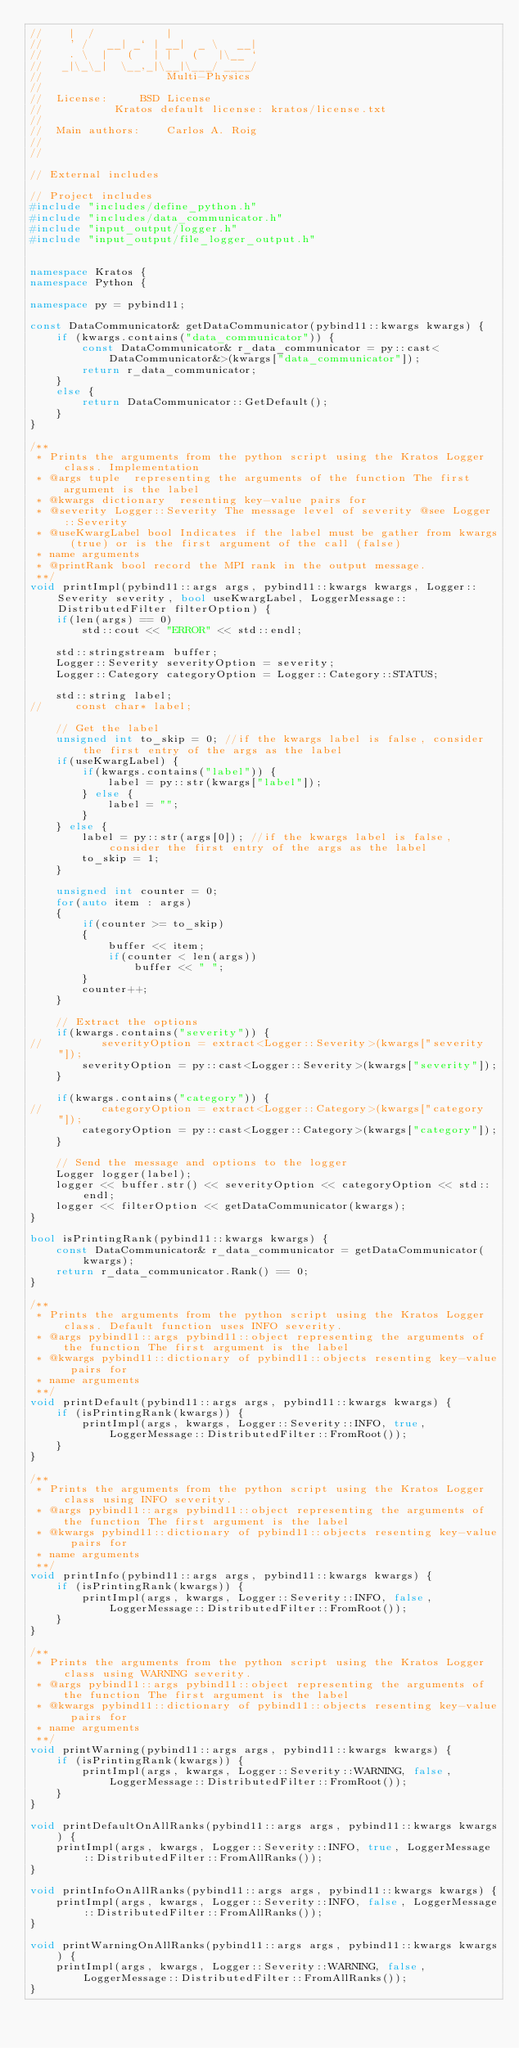<code> <loc_0><loc_0><loc_500><loc_500><_C++_>//    |  /           |
//    ' /   __| _` | __|  _ \   __|
//    . \  |   (   | |   (   |\__ `
//   _|\_\_|  \__,_|\__|\___/ ____/
//                   Multi-Physics
//
//  License:		 BSD License
//					 Kratos default license: kratos/license.txt
//
//  Main authors:    Carlos A. Roig
//
//

// External includes

// Project includes
#include "includes/define_python.h"
#include "includes/data_communicator.h"
#include "input_output/logger.h"
#include "input_output/file_logger_output.h"


namespace Kratos {
namespace Python {

namespace py = pybind11;

const DataCommunicator& getDataCommunicator(pybind11::kwargs kwargs) {
    if (kwargs.contains("data_communicator")) {
        const DataCommunicator& r_data_communicator = py::cast<DataCommunicator&>(kwargs["data_communicator"]);
        return r_data_communicator;
    }
    else {
        return DataCommunicator::GetDefault();
    }
}

/**
 * Prints the arguments from the python script using the Kratos Logger class. Implementation
 * @args tuple  representing the arguments of the function The first argument is the label
 * @kwargs dictionary  resenting key-value pairs for
 * @severity Logger::Severity The message level of severity @see Logger::Severity
 * @useKwargLabel bool Indicates if the label must be gather from kwargs (true) or is the first argument of the call (false)
 * name arguments
 * @printRank bool record the MPI rank in the output message.
 **/
void printImpl(pybind11::args args, pybind11::kwargs kwargs, Logger::Severity severity, bool useKwargLabel, LoggerMessage::DistributedFilter filterOption) {
    if(len(args) == 0)
        std::cout << "ERROR" << std::endl;

    std::stringstream buffer;
    Logger::Severity severityOption = severity;
    Logger::Category categoryOption = Logger::Category::STATUS;

    std::string label;
//     const char* label;

    // Get the label
    unsigned int to_skip = 0; //if the kwargs label is false, consider the first entry of the args as the label
    if(useKwargLabel) {
        if(kwargs.contains("label")) {
            label = py::str(kwargs["label"]);
        } else {
            label = "";
        }
    } else {
        label = py::str(args[0]); //if the kwargs label is false, consider the first entry of the args as the label
        to_skip = 1;
    }

    unsigned int counter = 0;
    for(auto item : args)
    {
        if(counter >= to_skip)
        {
            buffer << item;
            if(counter < len(args))
                buffer << " ";
        }
        counter++;
    }

    // Extract the options
    if(kwargs.contains("severity")) {
//         severityOption = extract<Logger::Severity>(kwargs["severity"]);
        severityOption = py::cast<Logger::Severity>(kwargs["severity"]);
    }

    if(kwargs.contains("category")) {
//         categoryOption = extract<Logger::Category>(kwargs["category"]);
        categoryOption = py::cast<Logger::Category>(kwargs["category"]);
    }

    // Send the message and options to the logger
    Logger logger(label);
    logger << buffer.str() << severityOption << categoryOption << std::endl;
    logger << filterOption << getDataCommunicator(kwargs);
}

bool isPrintingRank(pybind11::kwargs kwargs) {
    const DataCommunicator& r_data_communicator = getDataCommunicator(kwargs);
    return r_data_communicator.Rank() == 0;
}

/**
 * Prints the arguments from the python script using the Kratos Logger class. Default function uses INFO severity.
 * @args pybind11::args pybind11::object representing the arguments of the function The first argument is the label
 * @kwargs pybind11::dictionary of pybind11::objects resenting key-value pairs for
 * name arguments
 **/
void printDefault(pybind11::args args, pybind11::kwargs kwargs) {
    if (isPrintingRank(kwargs)) {
        printImpl(args, kwargs, Logger::Severity::INFO, true, LoggerMessage::DistributedFilter::FromRoot());
    }
}

/**
 * Prints the arguments from the python script using the Kratos Logger class using INFO severity.
 * @args pybind11::args pybind11::object representing the arguments of the function The first argument is the label
 * @kwargs pybind11::dictionary of pybind11::objects resenting key-value pairs for
 * name arguments
 **/
void printInfo(pybind11::args args, pybind11::kwargs kwargs) {
    if (isPrintingRank(kwargs)) {
        printImpl(args, kwargs, Logger::Severity::INFO, false, LoggerMessage::DistributedFilter::FromRoot());
    }
}

/**
 * Prints the arguments from the python script using the Kratos Logger class using WARNING severity.
 * @args pybind11::args pybind11::object representing the arguments of the function The first argument is the label
 * @kwargs pybind11::dictionary of pybind11::objects resenting key-value pairs for
 * name arguments
 **/
void printWarning(pybind11::args args, pybind11::kwargs kwargs) {
    if (isPrintingRank(kwargs)) {
        printImpl(args, kwargs, Logger::Severity::WARNING, false, LoggerMessage::DistributedFilter::FromRoot());
    }
}

void printDefaultOnAllRanks(pybind11::args args, pybind11::kwargs kwargs) {
    printImpl(args, kwargs, Logger::Severity::INFO, true, LoggerMessage::DistributedFilter::FromAllRanks());
}

void printInfoOnAllRanks(pybind11::args args, pybind11::kwargs kwargs) {
    printImpl(args, kwargs, Logger::Severity::INFO, false, LoggerMessage::DistributedFilter::FromAllRanks());
}

void printWarningOnAllRanks(pybind11::args args, pybind11::kwargs kwargs) {
    printImpl(args, kwargs, Logger::Severity::WARNING, false, LoggerMessage::DistributedFilter::FromAllRanks());
}
</code> 